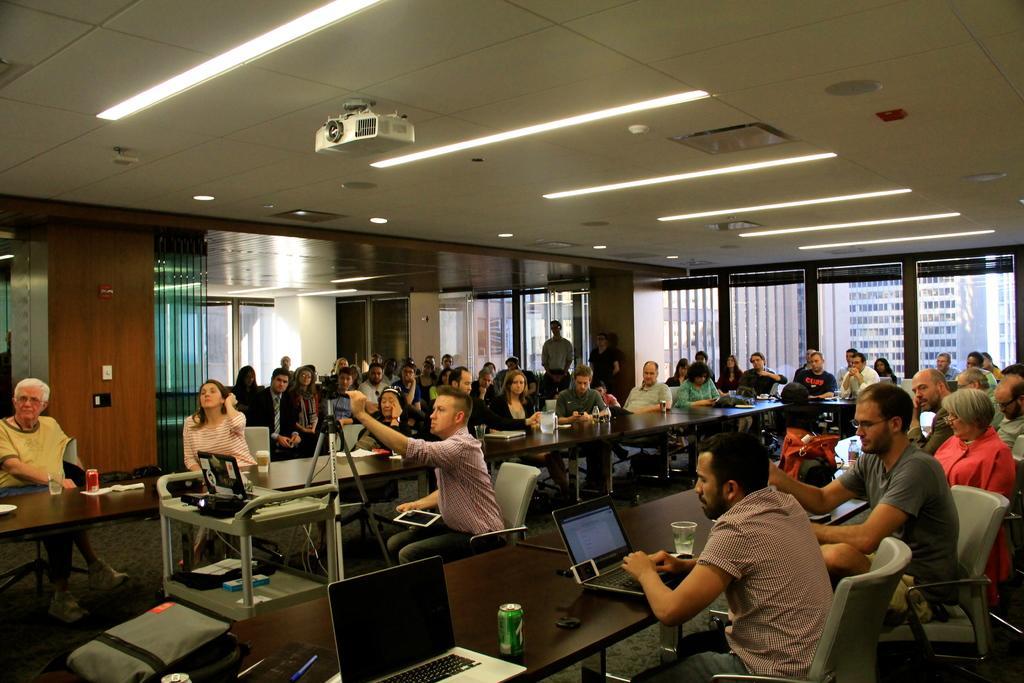In one or two sentences, can you explain what this image depicts? In this image there are group of people sitting in chair and in table there are jug , book , laptop, thin , glass, bag , camera fixed to tripod stand and in back ground there is projector, lights, window, building. 